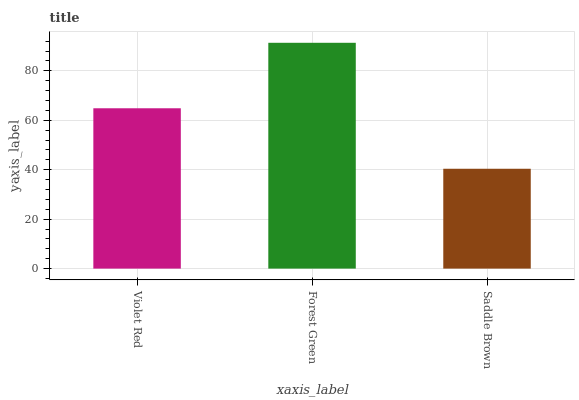Is Forest Green the minimum?
Answer yes or no. No. Is Saddle Brown the maximum?
Answer yes or no. No. Is Forest Green greater than Saddle Brown?
Answer yes or no. Yes. Is Saddle Brown less than Forest Green?
Answer yes or no. Yes. Is Saddle Brown greater than Forest Green?
Answer yes or no. No. Is Forest Green less than Saddle Brown?
Answer yes or no. No. Is Violet Red the high median?
Answer yes or no. Yes. Is Violet Red the low median?
Answer yes or no. Yes. Is Saddle Brown the high median?
Answer yes or no. No. Is Saddle Brown the low median?
Answer yes or no. No. 